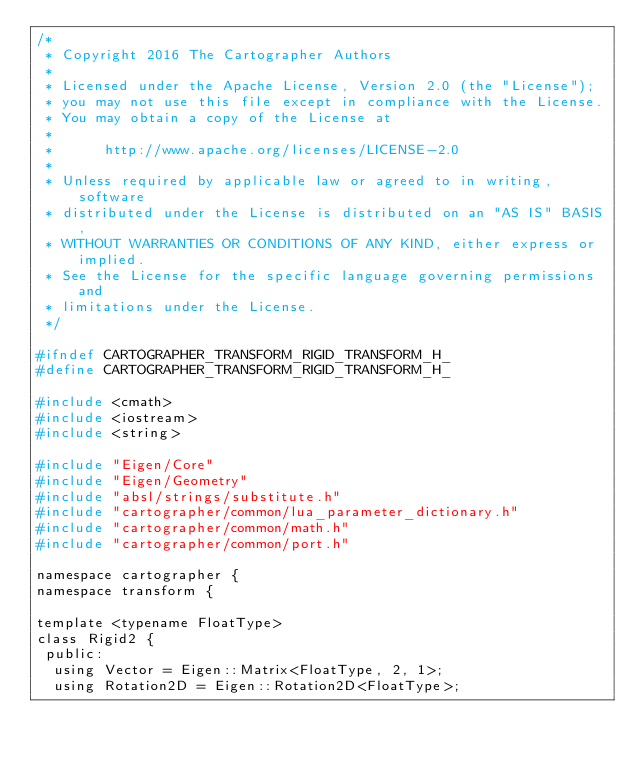<code> <loc_0><loc_0><loc_500><loc_500><_C_>/*
 * Copyright 2016 The Cartographer Authors
 *
 * Licensed under the Apache License, Version 2.0 (the "License");
 * you may not use this file except in compliance with the License.
 * You may obtain a copy of the License at
 *
 *      http://www.apache.org/licenses/LICENSE-2.0
 *
 * Unless required by applicable law or agreed to in writing, software
 * distributed under the License is distributed on an "AS IS" BASIS,
 * WITHOUT WARRANTIES OR CONDITIONS OF ANY KIND, either express or implied.
 * See the License for the specific language governing permissions and
 * limitations under the License.
 */

#ifndef CARTOGRAPHER_TRANSFORM_RIGID_TRANSFORM_H_
#define CARTOGRAPHER_TRANSFORM_RIGID_TRANSFORM_H_

#include <cmath>
#include <iostream>
#include <string>

#include "Eigen/Core"
#include "Eigen/Geometry"
#include "absl/strings/substitute.h"
#include "cartographer/common/lua_parameter_dictionary.h"
#include "cartographer/common/math.h"
#include "cartographer/common/port.h"

namespace cartographer {
namespace transform {

template <typename FloatType>
class Rigid2 {
 public:
  using Vector = Eigen::Matrix<FloatType, 2, 1>;
  using Rotation2D = Eigen::Rotation2D<FloatType>;
</code> 